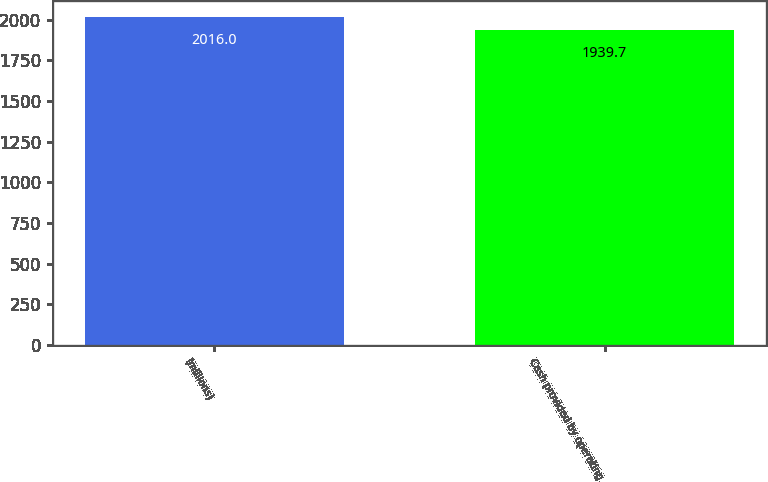Convert chart to OTSL. <chart><loc_0><loc_0><loc_500><loc_500><bar_chart><fcel>(millions)<fcel>Cash provided by operating<nl><fcel>2016<fcel>1939.7<nl></chart> 